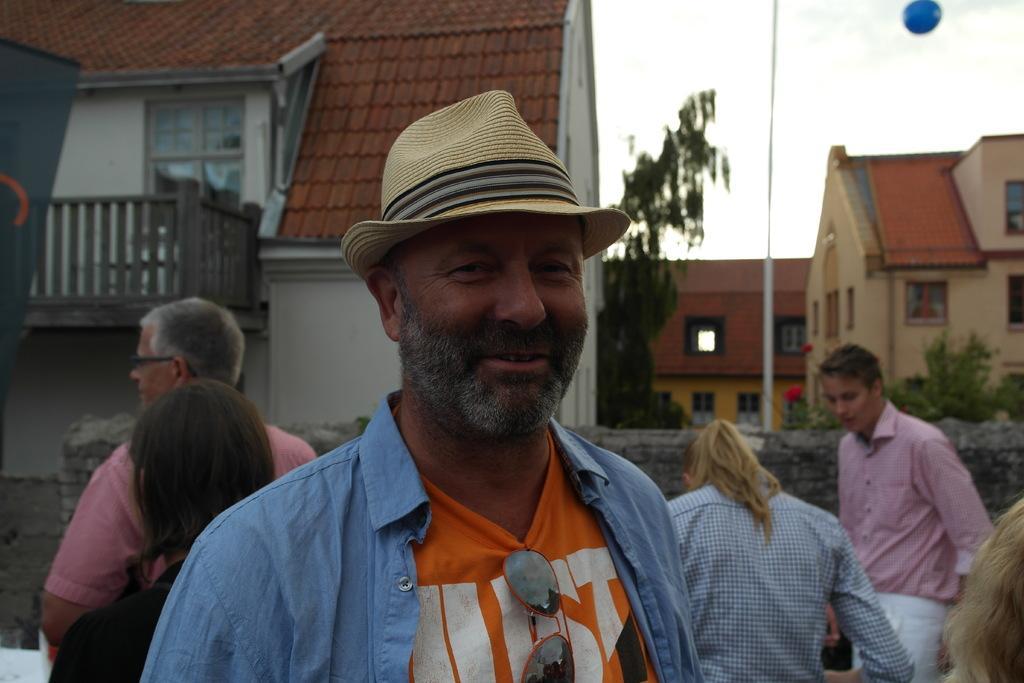Can you describe this image briefly? In this image I can see few people are standing. Here I can see one of them is wearing cream colour hat. In the background I can see few buildings, a pole, few trees and I can see this image is little bit blurry from background. 